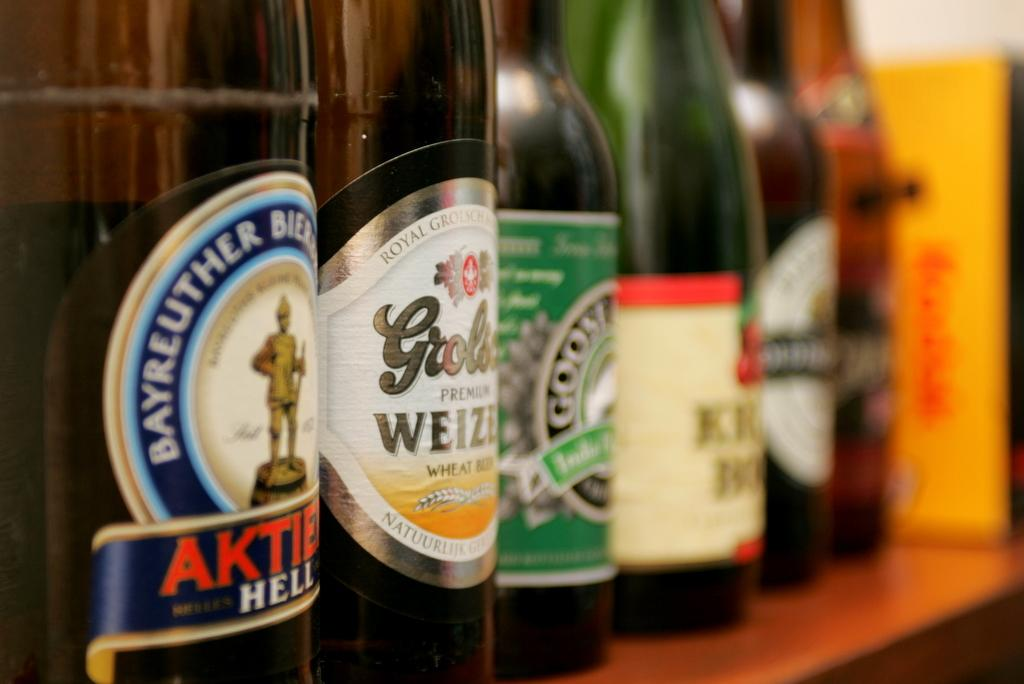<image>
Provide a brief description of the given image. A bottle with the partial word Aktie on its label next to many other bottles. 